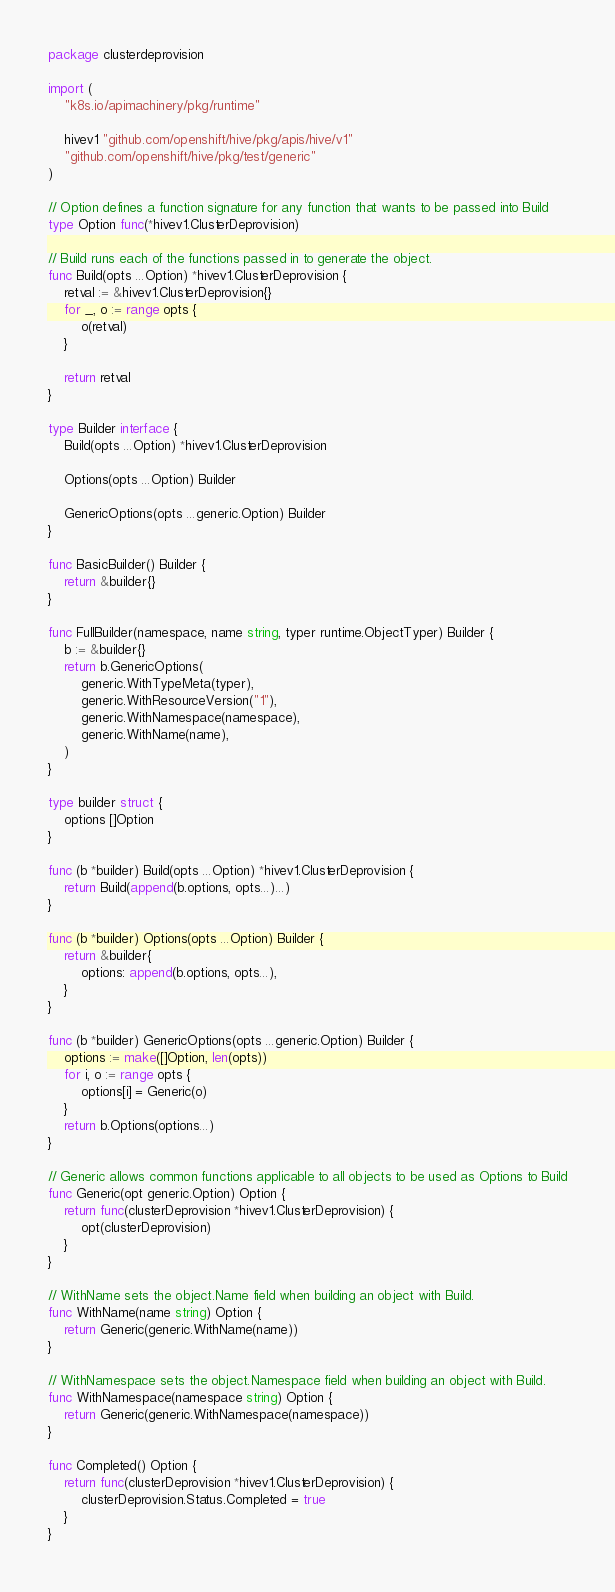<code> <loc_0><loc_0><loc_500><loc_500><_Go_>package clusterdeprovision

import (
	"k8s.io/apimachinery/pkg/runtime"

	hivev1 "github.com/openshift/hive/pkg/apis/hive/v1"
	"github.com/openshift/hive/pkg/test/generic"
)

// Option defines a function signature for any function that wants to be passed into Build
type Option func(*hivev1.ClusterDeprovision)

// Build runs each of the functions passed in to generate the object.
func Build(opts ...Option) *hivev1.ClusterDeprovision {
	retval := &hivev1.ClusterDeprovision{}
	for _, o := range opts {
		o(retval)
	}

	return retval
}

type Builder interface {
	Build(opts ...Option) *hivev1.ClusterDeprovision

	Options(opts ...Option) Builder

	GenericOptions(opts ...generic.Option) Builder
}

func BasicBuilder() Builder {
	return &builder{}
}

func FullBuilder(namespace, name string, typer runtime.ObjectTyper) Builder {
	b := &builder{}
	return b.GenericOptions(
		generic.WithTypeMeta(typer),
		generic.WithResourceVersion("1"),
		generic.WithNamespace(namespace),
		generic.WithName(name),
	)
}

type builder struct {
	options []Option
}

func (b *builder) Build(opts ...Option) *hivev1.ClusterDeprovision {
	return Build(append(b.options, opts...)...)
}

func (b *builder) Options(opts ...Option) Builder {
	return &builder{
		options: append(b.options, opts...),
	}
}

func (b *builder) GenericOptions(opts ...generic.Option) Builder {
	options := make([]Option, len(opts))
	for i, o := range opts {
		options[i] = Generic(o)
	}
	return b.Options(options...)
}

// Generic allows common functions applicable to all objects to be used as Options to Build
func Generic(opt generic.Option) Option {
	return func(clusterDeprovision *hivev1.ClusterDeprovision) {
		opt(clusterDeprovision)
	}
}

// WithName sets the object.Name field when building an object with Build.
func WithName(name string) Option {
	return Generic(generic.WithName(name))
}

// WithNamespace sets the object.Namespace field when building an object with Build.
func WithNamespace(namespace string) Option {
	return Generic(generic.WithNamespace(namespace))
}

func Completed() Option {
	return func(clusterDeprovision *hivev1.ClusterDeprovision) {
		clusterDeprovision.Status.Completed = true
	}
}
</code> 